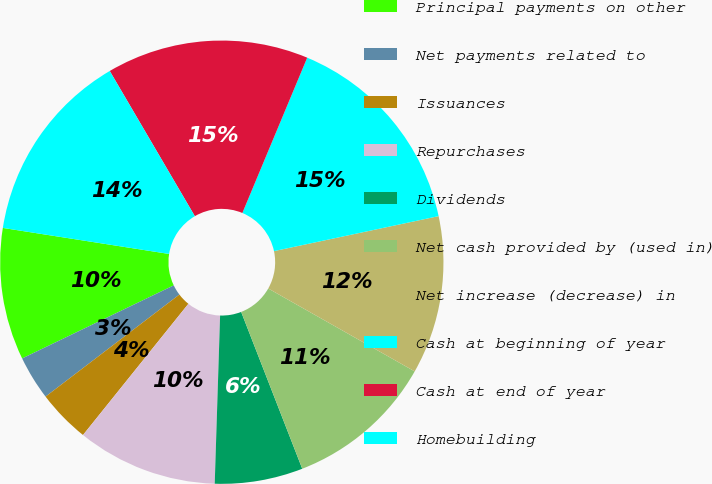<chart> <loc_0><loc_0><loc_500><loc_500><pie_chart><fcel>Principal payments on other<fcel>Net payments related to<fcel>Issuances<fcel>Repurchases<fcel>Dividends<fcel>Net cash provided by (used in)<fcel>Net increase (decrease) in<fcel>Cash at beginning of year<fcel>Cash at end of year<fcel>Homebuilding<nl><fcel>9.62%<fcel>3.22%<fcel>3.86%<fcel>10.26%<fcel>6.42%<fcel>10.89%<fcel>11.53%<fcel>15.37%<fcel>14.73%<fcel>14.09%<nl></chart> 